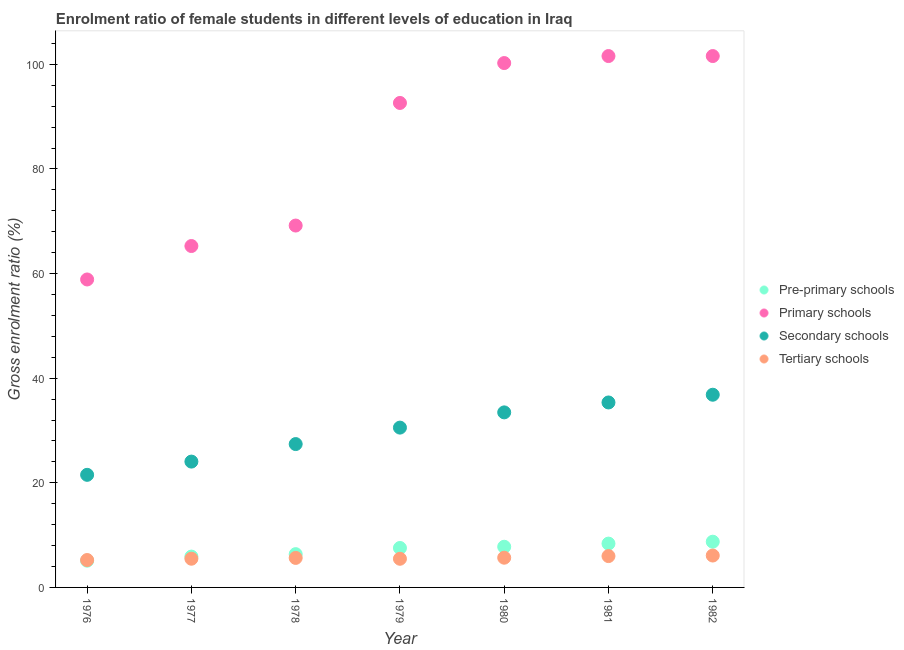What is the gross enrolment ratio(male) in pre-primary schools in 1979?
Provide a short and direct response. 7.54. Across all years, what is the maximum gross enrolment ratio(male) in tertiary schools?
Offer a very short reply. 6.1. Across all years, what is the minimum gross enrolment ratio(male) in tertiary schools?
Offer a very short reply. 5.24. In which year was the gross enrolment ratio(male) in pre-primary schools minimum?
Provide a short and direct response. 1976. What is the total gross enrolment ratio(male) in secondary schools in the graph?
Your answer should be compact. 209.22. What is the difference between the gross enrolment ratio(male) in pre-primary schools in 1977 and that in 1978?
Provide a short and direct response. -0.47. What is the difference between the gross enrolment ratio(male) in primary schools in 1979 and the gross enrolment ratio(male) in pre-primary schools in 1978?
Ensure brevity in your answer.  86.26. What is the average gross enrolment ratio(male) in primary schools per year?
Provide a short and direct response. 84.2. In the year 1982, what is the difference between the gross enrolment ratio(male) in tertiary schools and gross enrolment ratio(male) in primary schools?
Ensure brevity in your answer.  -95.49. What is the ratio of the gross enrolment ratio(male) in primary schools in 1978 to that in 1982?
Make the answer very short. 0.68. What is the difference between the highest and the second highest gross enrolment ratio(male) in primary schools?
Your answer should be very brief. 0. What is the difference between the highest and the lowest gross enrolment ratio(male) in tertiary schools?
Provide a short and direct response. 0.86. Is it the case that in every year, the sum of the gross enrolment ratio(male) in tertiary schools and gross enrolment ratio(male) in primary schools is greater than the sum of gross enrolment ratio(male) in pre-primary schools and gross enrolment ratio(male) in secondary schools?
Provide a short and direct response. Yes. Is it the case that in every year, the sum of the gross enrolment ratio(male) in pre-primary schools and gross enrolment ratio(male) in primary schools is greater than the gross enrolment ratio(male) in secondary schools?
Make the answer very short. Yes. Does the gross enrolment ratio(male) in tertiary schools monotonically increase over the years?
Your answer should be compact. No. Is the gross enrolment ratio(male) in secondary schools strictly less than the gross enrolment ratio(male) in tertiary schools over the years?
Offer a terse response. No. How many dotlines are there?
Your answer should be compact. 4. How many years are there in the graph?
Offer a terse response. 7. Are the values on the major ticks of Y-axis written in scientific E-notation?
Provide a succinct answer. No. How many legend labels are there?
Your response must be concise. 4. How are the legend labels stacked?
Make the answer very short. Vertical. What is the title of the graph?
Provide a succinct answer. Enrolment ratio of female students in different levels of education in Iraq. What is the label or title of the X-axis?
Your answer should be very brief. Year. What is the label or title of the Y-axis?
Ensure brevity in your answer.  Gross enrolment ratio (%). What is the Gross enrolment ratio (%) in Pre-primary schools in 1976?
Offer a very short reply. 5.12. What is the Gross enrolment ratio (%) of Primary schools in 1976?
Your answer should be very brief. 58.88. What is the Gross enrolment ratio (%) of Secondary schools in 1976?
Provide a short and direct response. 21.53. What is the Gross enrolment ratio (%) of Tertiary schools in 1976?
Keep it short and to the point. 5.24. What is the Gross enrolment ratio (%) of Pre-primary schools in 1977?
Give a very brief answer. 5.89. What is the Gross enrolment ratio (%) in Primary schools in 1977?
Your response must be concise. 65.27. What is the Gross enrolment ratio (%) of Secondary schools in 1977?
Offer a terse response. 24.06. What is the Gross enrolment ratio (%) of Tertiary schools in 1977?
Provide a succinct answer. 5.49. What is the Gross enrolment ratio (%) of Pre-primary schools in 1978?
Provide a succinct answer. 6.36. What is the Gross enrolment ratio (%) in Primary schools in 1978?
Your answer should be compact. 69.19. What is the Gross enrolment ratio (%) in Secondary schools in 1978?
Your answer should be compact. 27.41. What is the Gross enrolment ratio (%) of Tertiary schools in 1978?
Offer a terse response. 5.64. What is the Gross enrolment ratio (%) of Pre-primary schools in 1979?
Your response must be concise. 7.54. What is the Gross enrolment ratio (%) in Primary schools in 1979?
Provide a short and direct response. 92.63. What is the Gross enrolment ratio (%) in Secondary schools in 1979?
Your response must be concise. 30.55. What is the Gross enrolment ratio (%) in Tertiary schools in 1979?
Make the answer very short. 5.48. What is the Gross enrolment ratio (%) in Pre-primary schools in 1980?
Offer a terse response. 7.77. What is the Gross enrolment ratio (%) in Primary schools in 1980?
Your answer should be compact. 100.25. What is the Gross enrolment ratio (%) of Secondary schools in 1980?
Offer a terse response. 33.47. What is the Gross enrolment ratio (%) of Tertiary schools in 1980?
Offer a terse response. 5.68. What is the Gross enrolment ratio (%) in Pre-primary schools in 1981?
Your answer should be very brief. 8.38. What is the Gross enrolment ratio (%) in Primary schools in 1981?
Provide a short and direct response. 101.59. What is the Gross enrolment ratio (%) in Secondary schools in 1981?
Your response must be concise. 35.36. What is the Gross enrolment ratio (%) of Tertiary schools in 1981?
Offer a very short reply. 5.99. What is the Gross enrolment ratio (%) of Pre-primary schools in 1982?
Ensure brevity in your answer.  8.74. What is the Gross enrolment ratio (%) in Primary schools in 1982?
Make the answer very short. 101.59. What is the Gross enrolment ratio (%) in Secondary schools in 1982?
Keep it short and to the point. 36.84. What is the Gross enrolment ratio (%) in Tertiary schools in 1982?
Keep it short and to the point. 6.1. Across all years, what is the maximum Gross enrolment ratio (%) of Pre-primary schools?
Your answer should be compact. 8.74. Across all years, what is the maximum Gross enrolment ratio (%) of Primary schools?
Offer a terse response. 101.59. Across all years, what is the maximum Gross enrolment ratio (%) of Secondary schools?
Make the answer very short. 36.84. Across all years, what is the maximum Gross enrolment ratio (%) in Tertiary schools?
Your answer should be compact. 6.1. Across all years, what is the minimum Gross enrolment ratio (%) of Pre-primary schools?
Offer a terse response. 5.12. Across all years, what is the minimum Gross enrolment ratio (%) in Primary schools?
Keep it short and to the point. 58.88. Across all years, what is the minimum Gross enrolment ratio (%) in Secondary schools?
Provide a short and direct response. 21.53. Across all years, what is the minimum Gross enrolment ratio (%) in Tertiary schools?
Offer a very short reply. 5.24. What is the total Gross enrolment ratio (%) of Pre-primary schools in the graph?
Ensure brevity in your answer.  49.81. What is the total Gross enrolment ratio (%) of Primary schools in the graph?
Your answer should be compact. 589.4. What is the total Gross enrolment ratio (%) of Secondary schools in the graph?
Give a very brief answer. 209.22. What is the total Gross enrolment ratio (%) in Tertiary schools in the graph?
Offer a terse response. 39.62. What is the difference between the Gross enrolment ratio (%) in Pre-primary schools in 1976 and that in 1977?
Your answer should be very brief. -0.78. What is the difference between the Gross enrolment ratio (%) in Primary schools in 1976 and that in 1977?
Your response must be concise. -6.39. What is the difference between the Gross enrolment ratio (%) of Secondary schools in 1976 and that in 1977?
Your answer should be very brief. -2.53. What is the difference between the Gross enrolment ratio (%) in Tertiary schools in 1976 and that in 1977?
Offer a terse response. -0.25. What is the difference between the Gross enrolment ratio (%) of Pre-primary schools in 1976 and that in 1978?
Your answer should be very brief. -1.25. What is the difference between the Gross enrolment ratio (%) of Primary schools in 1976 and that in 1978?
Offer a terse response. -10.31. What is the difference between the Gross enrolment ratio (%) of Secondary schools in 1976 and that in 1978?
Your answer should be very brief. -5.88. What is the difference between the Gross enrolment ratio (%) of Tertiary schools in 1976 and that in 1978?
Offer a terse response. -0.4. What is the difference between the Gross enrolment ratio (%) in Pre-primary schools in 1976 and that in 1979?
Keep it short and to the point. -2.43. What is the difference between the Gross enrolment ratio (%) in Primary schools in 1976 and that in 1979?
Provide a short and direct response. -33.75. What is the difference between the Gross enrolment ratio (%) in Secondary schools in 1976 and that in 1979?
Ensure brevity in your answer.  -9.03. What is the difference between the Gross enrolment ratio (%) in Tertiary schools in 1976 and that in 1979?
Give a very brief answer. -0.24. What is the difference between the Gross enrolment ratio (%) in Pre-primary schools in 1976 and that in 1980?
Your response must be concise. -2.66. What is the difference between the Gross enrolment ratio (%) of Primary schools in 1976 and that in 1980?
Offer a terse response. -41.38. What is the difference between the Gross enrolment ratio (%) in Secondary schools in 1976 and that in 1980?
Offer a very short reply. -11.94. What is the difference between the Gross enrolment ratio (%) of Tertiary schools in 1976 and that in 1980?
Offer a terse response. -0.44. What is the difference between the Gross enrolment ratio (%) in Pre-primary schools in 1976 and that in 1981?
Offer a terse response. -3.26. What is the difference between the Gross enrolment ratio (%) in Primary schools in 1976 and that in 1981?
Keep it short and to the point. -42.71. What is the difference between the Gross enrolment ratio (%) of Secondary schools in 1976 and that in 1981?
Your answer should be compact. -13.84. What is the difference between the Gross enrolment ratio (%) of Tertiary schools in 1976 and that in 1981?
Provide a short and direct response. -0.75. What is the difference between the Gross enrolment ratio (%) in Pre-primary schools in 1976 and that in 1982?
Offer a very short reply. -3.63. What is the difference between the Gross enrolment ratio (%) in Primary schools in 1976 and that in 1982?
Your response must be concise. -42.71. What is the difference between the Gross enrolment ratio (%) of Secondary schools in 1976 and that in 1982?
Provide a short and direct response. -15.31. What is the difference between the Gross enrolment ratio (%) in Tertiary schools in 1976 and that in 1982?
Give a very brief answer. -0.86. What is the difference between the Gross enrolment ratio (%) of Pre-primary schools in 1977 and that in 1978?
Provide a short and direct response. -0.47. What is the difference between the Gross enrolment ratio (%) of Primary schools in 1977 and that in 1978?
Ensure brevity in your answer.  -3.91. What is the difference between the Gross enrolment ratio (%) of Secondary schools in 1977 and that in 1978?
Provide a succinct answer. -3.35. What is the difference between the Gross enrolment ratio (%) of Tertiary schools in 1977 and that in 1978?
Provide a short and direct response. -0.15. What is the difference between the Gross enrolment ratio (%) in Pre-primary schools in 1977 and that in 1979?
Ensure brevity in your answer.  -1.65. What is the difference between the Gross enrolment ratio (%) of Primary schools in 1977 and that in 1979?
Give a very brief answer. -27.35. What is the difference between the Gross enrolment ratio (%) in Secondary schools in 1977 and that in 1979?
Offer a terse response. -6.5. What is the difference between the Gross enrolment ratio (%) in Tertiary schools in 1977 and that in 1979?
Offer a terse response. 0.01. What is the difference between the Gross enrolment ratio (%) in Pre-primary schools in 1977 and that in 1980?
Your response must be concise. -1.88. What is the difference between the Gross enrolment ratio (%) of Primary schools in 1977 and that in 1980?
Give a very brief answer. -34.98. What is the difference between the Gross enrolment ratio (%) in Secondary schools in 1977 and that in 1980?
Make the answer very short. -9.41. What is the difference between the Gross enrolment ratio (%) in Tertiary schools in 1977 and that in 1980?
Offer a terse response. -0.19. What is the difference between the Gross enrolment ratio (%) in Pre-primary schools in 1977 and that in 1981?
Provide a succinct answer. -2.49. What is the difference between the Gross enrolment ratio (%) of Primary schools in 1977 and that in 1981?
Keep it short and to the point. -36.32. What is the difference between the Gross enrolment ratio (%) in Secondary schools in 1977 and that in 1981?
Ensure brevity in your answer.  -11.31. What is the difference between the Gross enrolment ratio (%) of Tertiary schools in 1977 and that in 1981?
Give a very brief answer. -0.5. What is the difference between the Gross enrolment ratio (%) in Pre-primary schools in 1977 and that in 1982?
Keep it short and to the point. -2.85. What is the difference between the Gross enrolment ratio (%) of Primary schools in 1977 and that in 1982?
Provide a succinct answer. -36.32. What is the difference between the Gross enrolment ratio (%) of Secondary schools in 1977 and that in 1982?
Provide a short and direct response. -12.78. What is the difference between the Gross enrolment ratio (%) of Tertiary schools in 1977 and that in 1982?
Your response must be concise. -0.61. What is the difference between the Gross enrolment ratio (%) in Pre-primary schools in 1978 and that in 1979?
Offer a very short reply. -1.18. What is the difference between the Gross enrolment ratio (%) in Primary schools in 1978 and that in 1979?
Your answer should be compact. -23.44. What is the difference between the Gross enrolment ratio (%) in Secondary schools in 1978 and that in 1979?
Give a very brief answer. -3.15. What is the difference between the Gross enrolment ratio (%) of Tertiary schools in 1978 and that in 1979?
Your response must be concise. 0.16. What is the difference between the Gross enrolment ratio (%) of Pre-primary schools in 1978 and that in 1980?
Ensure brevity in your answer.  -1.41. What is the difference between the Gross enrolment ratio (%) in Primary schools in 1978 and that in 1980?
Provide a short and direct response. -31.07. What is the difference between the Gross enrolment ratio (%) of Secondary schools in 1978 and that in 1980?
Your answer should be very brief. -6.06. What is the difference between the Gross enrolment ratio (%) in Tertiary schools in 1978 and that in 1980?
Provide a short and direct response. -0.04. What is the difference between the Gross enrolment ratio (%) in Pre-primary schools in 1978 and that in 1981?
Provide a succinct answer. -2.02. What is the difference between the Gross enrolment ratio (%) in Primary schools in 1978 and that in 1981?
Provide a succinct answer. -32.41. What is the difference between the Gross enrolment ratio (%) of Secondary schools in 1978 and that in 1981?
Your response must be concise. -7.96. What is the difference between the Gross enrolment ratio (%) in Tertiary schools in 1978 and that in 1981?
Your answer should be compact. -0.35. What is the difference between the Gross enrolment ratio (%) of Pre-primary schools in 1978 and that in 1982?
Provide a short and direct response. -2.38. What is the difference between the Gross enrolment ratio (%) in Primary schools in 1978 and that in 1982?
Offer a terse response. -32.41. What is the difference between the Gross enrolment ratio (%) of Secondary schools in 1978 and that in 1982?
Make the answer very short. -9.43. What is the difference between the Gross enrolment ratio (%) of Tertiary schools in 1978 and that in 1982?
Your response must be concise. -0.45. What is the difference between the Gross enrolment ratio (%) of Pre-primary schools in 1979 and that in 1980?
Offer a very short reply. -0.23. What is the difference between the Gross enrolment ratio (%) in Primary schools in 1979 and that in 1980?
Your response must be concise. -7.63. What is the difference between the Gross enrolment ratio (%) of Secondary schools in 1979 and that in 1980?
Your answer should be very brief. -2.91. What is the difference between the Gross enrolment ratio (%) of Tertiary schools in 1979 and that in 1980?
Provide a short and direct response. -0.2. What is the difference between the Gross enrolment ratio (%) of Pre-primary schools in 1979 and that in 1981?
Your answer should be very brief. -0.84. What is the difference between the Gross enrolment ratio (%) of Primary schools in 1979 and that in 1981?
Offer a very short reply. -8.97. What is the difference between the Gross enrolment ratio (%) of Secondary schools in 1979 and that in 1981?
Your answer should be very brief. -4.81. What is the difference between the Gross enrolment ratio (%) in Tertiary schools in 1979 and that in 1981?
Provide a short and direct response. -0.51. What is the difference between the Gross enrolment ratio (%) of Pre-primary schools in 1979 and that in 1982?
Offer a very short reply. -1.2. What is the difference between the Gross enrolment ratio (%) of Primary schools in 1979 and that in 1982?
Give a very brief answer. -8.97. What is the difference between the Gross enrolment ratio (%) in Secondary schools in 1979 and that in 1982?
Offer a very short reply. -6.29. What is the difference between the Gross enrolment ratio (%) in Tertiary schools in 1979 and that in 1982?
Ensure brevity in your answer.  -0.62. What is the difference between the Gross enrolment ratio (%) of Pre-primary schools in 1980 and that in 1981?
Offer a terse response. -0.6. What is the difference between the Gross enrolment ratio (%) in Primary schools in 1980 and that in 1981?
Ensure brevity in your answer.  -1.34. What is the difference between the Gross enrolment ratio (%) of Secondary schools in 1980 and that in 1981?
Provide a succinct answer. -1.9. What is the difference between the Gross enrolment ratio (%) in Tertiary schools in 1980 and that in 1981?
Keep it short and to the point. -0.31. What is the difference between the Gross enrolment ratio (%) in Pre-primary schools in 1980 and that in 1982?
Your answer should be compact. -0.97. What is the difference between the Gross enrolment ratio (%) of Primary schools in 1980 and that in 1982?
Provide a succinct answer. -1.34. What is the difference between the Gross enrolment ratio (%) in Secondary schools in 1980 and that in 1982?
Provide a short and direct response. -3.37. What is the difference between the Gross enrolment ratio (%) in Tertiary schools in 1980 and that in 1982?
Your response must be concise. -0.41. What is the difference between the Gross enrolment ratio (%) of Pre-primary schools in 1981 and that in 1982?
Ensure brevity in your answer.  -0.36. What is the difference between the Gross enrolment ratio (%) of Primary schools in 1981 and that in 1982?
Your answer should be very brief. -0. What is the difference between the Gross enrolment ratio (%) in Secondary schools in 1981 and that in 1982?
Give a very brief answer. -1.48. What is the difference between the Gross enrolment ratio (%) in Tertiary schools in 1981 and that in 1982?
Give a very brief answer. -0.1. What is the difference between the Gross enrolment ratio (%) of Pre-primary schools in 1976 and the Gross enrolment ratio (%) of Primary schools in 1977?
Provide a short and direct response. -60.16. What is the difference between the Gross enrolment ratio (%) in Pre-primary schools in 1976 and the Gross enrolment ratio (%) in Secondary schools in 1977?
Provide a succinct answer. -18.94. What is the difference between the Gross enrolment ratio (%) of Pre-primary schools in 1976 and the Gross enrolment ratio (%) of Tertiary schools in 1977?
Offer a very short reply. -0.37. What is the difference between the Gross enrolment ratio (%) in Primary schools in 1976 and the Gross enrolment ratio (%) in Secondary schools in 1977?
Ensure brevity in your answer.  34.82. What is the difference between the Gross enrolment ratio (%) in Primary schools in 1976 and the Gross enrolment ratio (%) in Tertiary schools in 1977?
Provide a succinct answer. 53.39. What is the difference between the Gross enrolment ratio (%) in Secondary schools in 1976 and the Gross enrolment ratio (%) in Tertiary schools in 1977?
Your answer should be very brief. 16.04. What is the difference between the Gross enrolment ratio (%) in Pre-primary schools in 1976 and the Gross enrolment ratio (%) in Primary schools in 1978?
Offer a very short reply. -64.07. What is the difference between the Gross enrolment ratio (%) of Pre-primary schools in 1976 and the Gross enrolment ratio (%) of Secondary schools in 1978?
Your response must be concise. -22.29. What is the difference between the Gross enrolment ratio (%) of Pre-primary schools in 1976 and the Gross enrolment ratio (%) of Tertiary schools in 1978?
Offer a very short reply. -0.53. What is the difference between the Gross enrolment ratio (%) of Primary schools in 1976 and the Gross enrolment ratio (%) of Secondary schools in 1978?
Provide a short and direct response. 31.47. What is the difference between the Gross enrolment ratio (%) of Primary schools in 1976 and the Gross enrolment ratio (%) of Tertiary schools in 1978?
Your answer should be very brief. 53.24. What is the difference between the Gross enrolment ratio (%) in Secondary schools in 1976 and the Gross enrolment ratio (%) in Tertiary schools in 1978?
Offer a terse response. 15.88. What is the difference between the Gross enrolment ratio (%) in Pre-primary schools in 1976 and the Gross enrolment ratio (%) in Primary schools in 1979?
Offer a terse response. -87.51. What is the difference between the Gross enrolment ratio (%) of Pre-primary schools in 1976 and the Gross enrolment ratio (%) of Secondary schools in 1979?
Ensure brevity in your answer.  -25.44. What is the difference between the Gross enrolment ratio (%) in Pre-primary schools in 1976 and the Gross enrolment ratio (%) in Tertiary schools in 1979?
Make the answer very short. -0.36. What is the difference between the Gross enrolment ratio (%) in Primary schools in 1976 and the Gross enrolment ratio (%) in Secondary schools in 1979?
Your answer should be compact. 28.32. What is the difference between the Gross enrolment ratio (%) of Primary schools in 1976 and the Gross enrolment ratio (%) of Tertiary schools in 1979?
Offer a terse response. 53.4. What is the difference between the Gross enrolment ratio (%) in Secondary schools in 1976 and the Gross enrolment ratio (%) in Tertiary schools in 1979?
Your answer should be compact. 16.05. What is the difference between the Gross enrolment ratio (%) of Pre-primary schools in 1976 and the Gross enrolment ratio (%) of Primary schools in 1980?
Your response must be concise. -95.14. What is the difference between the Gross enrolment ratio (%) of Pre-primary schools in 1976 and the Gross enrolment ratio (%) of Secondary schools in 1980?
Make the answer very short. -28.35. What is the difference between the Gross enrolment ratio (%) of Pre-primary schools in 1976 and the Gross enrolment ratio (%) of Tertiary schools in 1980?
Give a very brief answer. -0.57. What is the difference between the Gross enrolment ratio (%) in Primary schools in 1976 and the Gross enrolment ratio (%) in Secondary schools in 1980?
Ensure brevity in your answer.  25.41. What is the difference between the Gross enrolment ratio (%) in Primary schools in 1976 and the Gross enrolment ratio (%) in Tertiary schools in 1980?
Make the answer very short. 53.2. What is the difference between the Gross enrolment ratio (%) in Secondary schools in 1976 and the Gross enrolment ratio (%) in Tertiary schools in 1980?
Offer a terse response. 15.84. What is the difference between the Gross enrolment ratio (%) in Pre-primary schools in 1976 and the Gross enrolment ratio (%) in Primary schools in 1981?
Keep it short and to the point. -96.48. What is the difference between the Gross enrolment ratio (%) in Pre-primary schools in 1976 and the Gross enrolment ratio (%) in Secondary schools in 1981?
Give a very brief answer. -30.25. What is the difference between the Gross enrolment ratio (%) in Pre-primary schools in 1976 and the Gross enrolment ratio (%) in Tertiary schools in 1981?
Offer a very short reply. -0.88. What is the difference between the Gross enrolment ratio (%) of Primary schools in 1976 and the Gross enrolment ratio (%) of Secondary schools in 1981?
Ensure brevity in your answer.  23.51. What is the difference between the Gross enrolment ratio (%) of Primary schools in 1976 and the Gross enrolment ratio (%) of Tertiary schools in 1981?
Offer a very short reply. 52.88. What is the difference between the Gross enrolment ratio (%) of Secondary schools in 1976 and the Gross enrolment ratio (%) of Tertiary schools in 1981?
Give a very brief answer. 15.53. What is the difference between the Gross enrolment ratio (%) of Pre-primary schools in 1976 and the Gross enrolment ratio (%) of Primary schools in 1982?
Provide a succinct answer. -96.48. What is the difference between the Gross enrolment ratio (%) of Pre-primary schools in 1976 and the Gross enrolment ratio (%) of Secondary schools in 1982?
Your answer should be very brief. -31.72. What is the difference between the Gross enrolment ratio (%) in Pre-primary schools in 1976 and the Gross enrolment ratio (%) in Tertiary schools in 1982?
Offer a very short reply. -0.98. What is the difference between the Gross enrolment ratio (%) in Primary schools in 1976 and the Gross enrolment ratio (%) in Secondary schools in 1982?
Offer a terse response. 22.04. What is the difference between the Gross enrolment ratio (%) of Primary schools in 1976 and the Gross enrolment ratio (%) of Tertiary schools in 1982?
Your answer should be compact. 52.78. What is the difference between the Gross enrolment ratio (%) of Secondary schools in 1976 and the Gross enrolment ratio (%) of Tertiary schools in 1982?
Keep it short and to the point. 15.43. What is the difference between the Gross enrolment ratio (%) in Pre-primary schools in 1977 and the Gross enrolment ratio (%) in Primary schools in 1978?
Ensure brevity in your answer.  -63.29. What is the difference between the Gross enrolment ratio (%) in Pre-primary schools in 1977 and the Gross enrolment ratio (%) in Secondary schools in 1978?
Offer a terse response. -21.51. What is the difference between the Gross enrolment ratio (%) in Pre-primary schools in 1977 and the Gross enrolment ratio (%) in Tertiary schools in 1978?
Your answer should be very brief. 0.25. What is the difference between the Gross enrolment ratio (%) in Primary schools in 1977 and the Gross enrolment ratio (%) in Secondary schools in 1978?
Your answer should be compact. 37.86. What is the difference between the Gross enrolment ratio (%) of Primary schools in 1977 and the Gross enrolment ratio (%) of Tertiary schools in 1978?
Your response must be concise. 59.63. What is the difference between the Gross enrolment ratio (%) of Secondary schools in 1977 and the Gross enrolment ratio (%) of Tertiary schools in 1978?
Offer a terse response. 18.42. What is the difference between the Gross enrolment ratio (%) in Pre-primary schools in 1977 and the Gross enrolment ratio (%) in Primary schools in 1979?
Provide a succinct answer. -86.73. What is the difference between the Gross enrolment ratio (%) of Pre-primary schools in 1977 and the Gross enrolment ratio (%) of Secondary schools in 1979?
Ensure brevity in your answer.  -24.66. What is the difference between the Gross enrolment ratio (%) in Pre-primary schools in 1977 and the Gross enrolment ratio (%) in Tertiary schools in 1979?
Give a very brief answer. 0.42. What is the difference between the Gross enrolment ratio (%) in Primary schools in 1977 and the Gross enrolment ratio (%) in Secondary schools in 1979?
Make the answer very short. 34.72. What is the difference between the Gross enrolment ratio (%) of Primary schools in 1977 and the Gross enrolment ratio (%) of Tertiary schools in 1979?
Provide a short and direct response. 59.79. What is the difference between the Gross enrolment ratio (%) of Secondary schools in 1977 and the Gross enrolment ratio (%) of Tertiary schools in 1979?
Provide a short and direct response. 18.58. What is the difference between the Gross enrolment ratio (%) in Pre-primary schools in 1977 and the Gross enrolment ratio (%) in Primary schools in 1980?
Your answer should be very brief. -94.36. What is the difference between the Gross enrolment ratio (%) in Pre-primary schools in 1977 and the Gross enrolment ratio (%) in Secondary schools in 1980?
Offer a terse response. -27.57. What is the difference between the Gross enrolment ratio (%) of Pre-primary schools in 1977 and the Gross enrolment ratio (%) of Tertiary schools in 1980?
Your answer should be compact. 0.21. What is the difference between the Gross enrolment ratio (%) of Primary schools in 1977 and the Gross enrolment ratio (%) of Secondary schools in 1980?
Your answer should be compact. 31.81. What is the difference between the Gross enrolment ratio (%) in Primary schools in 1977 and the Gross enrolment ratio (%) in Tertiary schools in 1980?
Keep it short and to the point. 59.59. What is the difference between the Gross enrolment ratio (%) of Secondary schools in 1977 and the Gross enrolment ratio (%) of Tertiary schools in 1980?
Give a very brief answer. 18.38. What is the difference between the Gross enrolment ratio (%) of Pre-primary schools in 1977 and the Gross enrolment ratio (%) of Primary schools in 1981?
Your answer should be compact. -95.7. What is the difference between the Gross enrolment ratio (%) of Pre-primary schools in 1977 and the Gross enrolment ratio (%) of Secondary schools in 1981?
Keep it short and to the point. -29.47. What is the difference between the Gross enrolment ratio (%) in Pre-primary schools in 1977 and the Gross enrolment ratio (%) in Tertiary schools in 1981?
Your answer should be compact. -0.1. What is the difference between the Gross enrolment ratio (%) of Primary schools in 1977 and the Gross enrolment ratio (%) of Secondary schools in 1981?
Make the answer very short. 29.91. What is the difference between the Gross enrolment ratio (%) in Primary schools in 1977 and the Gross enrolment ratio (%) in Tertiary schools in 1981?
Keep it short and to the point. 59.28. What is the difference between the Gross enrolment ratio (%) in Secondary schools in 1977 and the Gross enrolment ratio (%) in Tertiary schools in 1981?
Make the answer very short. 18.07. What is the difference between the Gross enrolment ratio (%) of Pre-primary schools in 1977 and the Gross enrolment ratio (%) of Primary schools in 1982?
Provide a short and direct response. -95.7. What is the difference between the Gross enrolment ratio (%) in Pre-primary schools in 1977 and the Gross enrolment ratio (%) in Secondary schools in 1982?
Ensure brevity in your answer.  -30.95. What is the difference between the Gross enrolment ratio (%) in Pre-primary schools in 1977 and the Gross enrolment ratio (%) in Tertiary schools in 1982?
Provide a short and direct response. -0.2. What is the difference between the Gross enrolment ratio (%) in Primary schools in 1977 and the Gross enrolment ratio (%) in Secondary schools in 1982?
Provide a short and direct response. 28.43. What is the difference between the Gross enrolment ratio (%) in Primary schools in 1977 and the Gross enrolment ratio (%) in Tertiary schools in 1982?
Keep it short and to the point. 59.17. What is the difference between the Gross enrolment ratio (%) of Secondary schools in 1977 and the Gross enrolment ratio (%) of Tertiary schools in 1982?
Make the answer very short. 17.96. What is the difference between the Gross enrolment ratio (%) of Pre-primary schools in 1978 and the Gross enrolment ratio (%) of Primary schools in 1979?
Offer a terse response. -86.26. What is the difference between the Gross enrolment ratio (%) in Pre-primary schools in 1978 and the Gross enrolment ratio (%) in Secondary schools in 1979?
Make the answer very short. -24.19. What is the difference between the Gross enrolment ratio (%) of Pre-primary schools in 1978 and the Gross enrolment ratio (%) of Tertiary schools in 1979?
Provide a short and direct response. 0.88. What is the difference between the Gross enrolment ratio (%) in Primary schools in 1978 and the Gross enrolment ratio (%) in Secondary schools in 1979?
Keep it short and to the point. 38.63. What is the difference between the Gross enrolment ratio (%) of Primary schools in 1978 and the Gross enrolment ratio (%) of Tertiary schools in 1979?
Offer a terse response. 63.71. What is the difference between the Gross enrolment ratio (%) of Secondary schools in 1978 and the Gross enrolment ratio (%) of Tertiary schools in 1979?
Your answer should be compact. 21.93. What is the difference between the Gross enrolment ratio (%) of Pre-primary schools in 1978 and the Gross enrolment ratio (%) of Primary schools in 1980?
Make the answer very short. -93.89. What is the difference between the Gross enrolment ratio (%) in Pre-primary schools in 1978 and the Gross enrolment ratio (%) in Secondary schools in 1980?
Provide a succinct answer. -27.1. What is the difference between the Gross enrolment ratio (%) in Pre-primary schools in 1978 and the Gross enrolment ratio (%) in Tertiary schools in 1980?
Your answer should be very brief. 0.68. What is the difference between the Gross enrolment ratio (%) of Primary schools in 1978 and the Gross enrolment ratio (%) of Secondary schools in 1980?
Your answer should be very brief. 35.72. What is the difference between the Gross enrolment ratio (%) in Primary schools in 1978 and the Gross enrolment ratio (%) in Tertiary schools in 1980?
Your response must be concise. 63.5. What is the difference between the Gross enrolment ratio (%) in Secondary schools in 1978 and the Gross enrolment ratio (%) in Tertiary schools in 1980?
Make the answer very short. 21.73. What is the difference between the Gross enrolment ratio (%) of Pre-primary schools in 1978 and the Gross enrolment ratio (%) of Primary schools in 1981?
Offer a very short reply. -95.23. What is the difference between the Gross enrolment ratio (%) in Pre-primary schools in 1978 and the Gross enrolment ratio (%) in Secondary schools in 1981?
Keep it short and to the point. -29. What is the difference between the Gross enrolment ratio (%) in Pre-primary schools in 1978 and the Gross enrolment ratio (%) in Tertiary schools in 1981?
Offer a very short reply. 0.37. What is the difference between the Gross enrolment ratio (%) in Primary schools in 1978 and the Gross enrolment ratio (%) in Secondary schools in 1981?
Provide a succinct answer. 33.82. What is the difference between the Gross enrolment ratio (%) of Primary schools in 1978 and the Gross enrolment ratio (%) of Tertiary schools in 1981?
Your response must be concise. 63.19. What is the difference between the Gross enrolment ratio (%) of Secondary schools in 1978 and the Gross enrolment ratio (%) of Tertiary schools in 1981?
Offer a terse response. 21.42. What is the difference between the Gross enrolment ratio (%) in Pre-primary schools in 1978 and the Gross enrolment ratio (%) in Primary schools in 1982?
Provide a succinct answer. -95.23. What is the difference between the Gross enrolment ratio (%) of Pre-primary schools in 1978 and the Gross enrolment ratio (%) of Secondary schools in 1982?
Make the answer very short. -30.48. What is the difference between the Gross enrolment ratio (%) of Pre-primary schools in 1978 and the Gross enrolment ratio (%) of Tertiary schools in 1982?
Your answer should be very brief. 0.26. What is the difference between the Gross enrolment ratio (%) of Primary schools in 1978 and the Gross enrolment ratio (%) of Secondary schools in 1982?
Offer a terse response. 32.35. What is the difference between the Gross enrolment ratio (%) in Primary schools in 1978 and the Gross enrolment ratio (%) in Tertiary schools in 1982?
Your answer should be compact. 63.09. What is the difference between the Gross enrolment ratio (%) of Secondary schools in 1978 and the Gross enrolment ratio (%) of Tertiary schools in 1982?
Give a very brief answer. 21.31. What is the difference between the Gross enrolment ratio (%) of Pre-primary schools in 1979 and the Gross enrolment ratio (%) of Primary schools in 1980?
Provide a short and direct response. -92.71. What is the difference between the Gross enrolment ratio (%) of Pre-primary schools in 1979 and the Gross enrolment ratio (%) of Secondary schools in 1980?
Offer a very short reply. -25.92. What is the difference between the Gross enrolment ratio (%) in Pre-primary schools in 1979 and the Gross enrolment ratio (%) in Tertiary schools in 1980?
Provide a succinct answer. 1.86. What is the difference between the Gross enrolment ratio (%) of Primary schools in 1979 and the Gross enrolment ratio (%) of Secondary schools in 1980?
Your answer should be very brief. 59.16. What is the difference between the Gross enrolment ratio (%) of Primary schools in 1979 and the Gross enrolment ratio (%) of Tertiary schools in 1980?
Offer a very short reply. 86.94. What is the difference between the Gross enrolment ratio (%) of Secondary schools in 1979 and the Gross enrolment ratio (%) of Tertiary schools in 1980?
Offer a very short reply. 24.87. What is the difference between the Gross enrolment ratio (%) in Pre-primary schools in 1979 and the Gross enrolment ratio (%) in Primary schools in 1981?
Give a very brief answer. -94.05. What is the difference between the Gross enrolment ratio (%) in Pre-primary schools in 1979 and the Gross enrolment ratio (%) in Secondary schools in 1981?
Offer a very short reply. -27.82. What is the difference between the Gross enrolment ratio (%) of Pre-primary schools in 1979 and the Gross enrolment ratio (%) of Tertiary schools in 1981?
Give a very brief answer. 1.55. What is the difference between the Gross enrolment ratio (%) of Primary schools in 1979 and the Gross enrolment ratio (%) of Secondary schools in 1981?
Your answer should be compact. 57.26. What is the difference between the Gross enrolment ratio (%) in Primary schools in 1979 and the Gross enrolment ratio (%) in Tertiary schools in 1981?
Keep it short and to the point. 86.63. What is the difference between the Gross enrolment ratio (%) of Secondary schools in 1979 and the Gross enrolment ratio (%) of Tertiary schools in 1981?
Make the answer very short. 24.56. What is the difference between the Gross enrolment ratio (%) in Pre-primary schools in 1979 and the Gross enrolment ratio (%) in Primary schools in 1982?
Keep it short and to the point. -94.05. What is the difference between the Gross enrolment ratio (%) in Pre-primary schools in 1979 and the Gross enrolment ratio (%) in Secondary schools in 1982?
Your answer should be compact. -29.3. What is the difference between the Gross enrolment ratio (%) of Pre-primary schools in 1979 and the Gross enrolment ratio (%) of Tertiary schools in 1982?
Provide a short and direct response. 1.45. What is the difference between the Gross enrolment ratio (%) of Primary schools in 1979 and the Gross enrolment ratio (%) of Secondary schools in 1982?
Give a very brief answer. 55.78. What is the difference between the Gross enrolment ratio (%) in Primary schools in 1979 and the Gross enrolment ratio (%) in Tertiary schools in 1982?
Offer a terse response. 86.53. What is the difference between the Gross enrolment ratio (%) in Secondary schools in 1979 and the Gross enrolment ratio (%) in Tertiary schools in 1982?
Your response must be concise. 24.46. What is the difference between the Gross enrolment ratio (%) in Pre-primary schools in 1980 and the Gross enrolment ratio (%) in Primary schools in 1981?
Ensure brevity in your answer.  -93.82. What is the difference between the Gross enrolment ratio (%) of Pre-primary schools in 1980 and the Gross enrolment ratio (%) of Secondary schools in 1981?
Ensure brevity in your answer.  -27.59. What is the difference between the Gross enrolment ratio (%) in Pre-primary schools in 1980 and the Gross enrolment ratio (%) in Tertiary schools in 1981?
Make the answer very short. 1.78. What is the difference between the Gross enrolment ratio (%) in Primary schools in 1980 and the Gross enrolment ratio (%) in Secondary schools in 1981?
Provide a succinct answer. 64.89. What is the difference between the Gross enrolment ratio (%) of Primary schools in 1980 and the Gross enrolment ratio (%) of Tertiary schools in 1981?
Keep it short and to the point. 94.26. What is the difference between the Gross enrolment ratio (%) of Secondary schools in 1980 and the Gross enrolment ratio (%) of Tertiary schools in 1981?
Provide a short and direct response. 27.47. What is the difference between the Gross enrolment ratio (%) in Pre-primary schools in 1980 and the Gross enrolment ratio (%) in Primary schools in 1982?
Your answer should be compact. -93.82. What is the difference between the Gross enrolment ratio (%) in Pre-primary schools in 1980 and the Gross enrolment ratio (%) in Secondary schools in 1982?
Your response must be concise. -29.07. What is the difference between the Gross enrolment ratio (%) in Pre-primary schools in 1980 and the Gross enrolment ratio (%) in Tertiary schools in 1982?
Your answer should be compact. 1.68. What is the difference between the Gross enrolment ratio (%) of Primary schools in 1980 and the Gross enrolment ratio (%) of Secondary schools in 1982?
Provide a succinct answer. 63.41. What is the difference between the Gross enrolment ratio (%) of Primary schools in 1980 and the Gross enrolment ratio (%) of Tertiary schools in 1982?
Offer a terse response. 94.16. What is the difference between the Gross enrolment ratio (%) in Secondary schools in 1980 and the Gross enrolment ratio (%) in Tertiary schools in 1982?
Provide a succinct answer. 27.37. What is the difference between the Gross enrolment ratio (%) in Pre-primary schools in 1981 and the Gross enrolment ratio (%) in Primary schools in 1982?
Your answer should be very brief. -93.21. What is the difference between the Gross enrolment ratio (%) of Pre-primary schools in 1981 and the Gross enrolment ratio (%) of Secondary schools in 1982?
Your answer should be compact. -28.46. What is the difference between the Gross enrolment ratio (%) of Pre-primary schools in 1981 and the Gross enrolment ratio (%) of Tertiary schools in 1982?
Your response must be concise. 2.28. What is the difference between the Gross enrolment ratio (%) in Primary schools in 1981 and the Gross enrolment ratio (%) in Secondary schools in 1982?
Offer a very short reply. 64.75. What is the difference between the Gross enrolment ratio (%) in Primary schools in 1981 and the Gross enrolment ratio (%) in Tertiary schools in 1982?
Provide a succinct answer. 95.49. What is the difference between the Gross enrolment ratio (%) in Secondary schools in 1981 and the Gross enrolment ratio (%) in Tertiary schools in 1982?
Provide a succinct answer. 29.27. What is the average Gross enrolment ratio (%) in Pre-primary schools per year?
Ensure brevity in your answer.  7.12. What is the average Gross enrolment ratio (%) of Primary schools per year?
Provide a succinct answer. 84.2. What is the average Gross enrolment ratio (%) in Secondary schools per year?
Your response must be concise. 29.89. What is the average Gross enrolment ratio (%) in Tertiary schools per year?
Provide a short and direct response. 5.66. In the year 1976, what is the difference between the Gross enrolment ratio (%) of Pre-primary schools and Gross enrolment ratio (%) of Primary schools?
Offer a very short reply. -53.76. In the year 1976, what is the difference between the Gross enrolment ratio (%) in Pre-primary schools and Gross enrolment ratio (%) in Secondary schools?
Offer a very short reply. -16.41. In the year 1976, what is the difference between the Gross enrolment ratio (%) of Pre-primary schools and Gross enrolment ratio (%) of Tertiary schools?
Give a very brief answer. -0.12. In the year 1976, what is the difference between the Gross enrolment ratio (%) in Primary schools and Gross enrolment ratio (%) in Secondary schools?
Give a very brief answer. 37.35. In the year 1976, what is the difference between the Gross enrolment ratio (%) in Primary schools and Gross enrolment ratio (%) in Tertiary schools?
Your response must be concise. 53.64. In the year 1976, what is the difference between the Gross enrolment ratio (%) of Secondary schools and Gross enrolment ratio (%) of Tertiary schools?
Give a very brief answer. 16.29. In the year 1977, what is the difference between the Gross enrolment ratio (%) of Pre-primary schools and Gross enrolment ratio (%) of Primary schools?
Keep it short and to the point. -59.38. In the year 1977, what is the difference between the Gross enrolment ratio (%) in Pre-primary schools and Gross enrolment ratio (%) in Secondary schools?
Keep it short and to the point. -18.16. In the year 1977, what is the difference between the Gross enrolment ratio (%) in Pre-primary schools and Gross enrolment ratio (%) in Tertiary schools?
Offer a terse response. 0.41. In the year 1977, what is the difference between the Gross enrolment ratio (%) in Primary schools and Gross enrolment ratio (%) in Secondary schools?
Make the answer very short. 41.21. In the year 1977, what is the difference between the Gross enrolment ratio (%) of Primary schools and Gross enrolment ratio (%) of Tertiary schools?
Give a very brief answer. 59.78. In the year 1977, what is the difference between the Gross enrolment ratio (%) in Secondary schools and Gross enrolment ratio (%) in Tertiary schools?
Make the answer very short. 18.57. In the year 1978, what is the difference between the Gross enrolment ratio (%) of Pre-primary schools and Gross enrolment ratio (%) of Primary schools?
Ensure brevity in your answer.  -62.82. In the year 1978, what is the difference between the Gross enrolment ratio (%) of Pre-primary schools and Gross enrolment ratio (%) of Secondary schools?
Your answer should be very brief. -21.05. In the year 1978, what is the difference between the Gross enrolment ratio (%) of Pre-primary schools and Gross enrolment ratio (%) of Tertiary schools?
Make the answer very short. 0.72. In the year 1978, what is the difference between the Gross enrolment ratio (%) of Primary schools and Gross enrolment ratio (%) of Secondary schools?
Provide a succinct answer. 41.78. In the year 1978, what is the difference between the Gross enrolment ratio (%) in Primary schools and Gross enrolment ratio (%) in Tertiary schools?
Make the answer very short. 63.54. In the year 1978, what is the difference between the Gross enrolment ratio (%) of Secondary schools and Gross enrolment ratio (%) of Tertiary schools?
Provide a succinct answer. 21.77. In the year 1979, what is the difference between the Gross enrolment ratio (%) in Pre-primary schools and Gross enrolment ratio (%) in Primary schools?
Give a very brief answer. -85.08. In the year 1979, what is the difference between the Gross enrolment ratio (%) of Pre-primary schools and Gross enrolment ratio (%) of Secondary schools?
Provide a short and direct response. -23.01. In the year 1979, what is the difference between the Gross enrolment ratio (%) in Pre-primary schools and Gross enrolment ratio (%) in Tertiary schools?
Your answer should be very brief. 2.06. In the year 1979, what is the difference between the Gross enrolment ratio (%) in Primary schools and Gross enrolment ratio (%) in Secondary schools?
Your answer should be very brief. 62.07. In the year 1979, what is the difference between the Gross enrolment ratio (%) in Primary schools and Gross enrolment ratio (%) in Tertiary schools?
Your answer should be very brief. 87.15. In the year 1979, what is the difference between the Gross enrolment ratio (%) in Secondary schools and Gross enrolment ratio (%) in Tertiary schools?
Make the answer very short. 25.08. In the year 1980, what is the difference between the Gross enrolment ratio (%) in Pre-primary schools and Gross enrolment ratio (%) in Primary schools?
Give a very brief answer. -92.48. In the year 1980, what is the difference between the Gross enrolment ratio (%) in Pre-primary schools and Gross enrolment ratio (%) in Secondary schools?
Make the answer very short. -25.69. In the year 1980, what is the difference between the Gross enrolment ratio (%) in Pre-primary schools and Gross enrolment ratio (%) in Tertiary schools?
Offer a terse response. 2.09. In the year 1980, what is the difference between the Gross enrolment ratio (%) in Primary schools and Gross enrolment ratio (%) in Secondary schools?
Offer a very short reply. 66.79. In the year 1980, what is the difference between the Gross enrolment ratio (%) of Primary schools and Gross enrolment ratio (%) of Tertiary schools?
Your answer should be very brief. 94.57. In the year 1980, what is the difference between the Gross enrolment ratio (%) of Secondary schools and Gross enrolment ratio (%) of Tertiary schools?
Provide a succinct answer. 27.78. In the year 1981, what is the difference between the Gross enrolment ratio (%) of Pre-primary schools and Gross enrolment ratio (%) of Primary schools?
Ensure brevity in your answer.  -93.21. In the year 1981, what is the difference between the Gross enrolment ratio (%) of Pre-primary schools and Gross enrolment ratio (%) of Secondary schools?
Provide a short and direct response. -26.98. In the year 1981, what is the difference between the Gross enrolment ratio (%) of Pre-primary schools and Gross enrolment ratio (%) of Tertiary schools?
Offer a very short reply. 2.39. In the year 1981, what is the difference between the Gross enrolment ratio (%) in Primary schools and Gross enrolment ratio (%) in Secondary schools?
Offer a terse response. 66.23. In the year 1981, what is the difference between the Gross enrolment ratio (%) in Primary schools and Gross enrolment ratio (%) in Tertiary schools?
Your response must be concise. 95.6. In the year 1981, what is the difference between the Gross enrolment ratio (%) of Secondary schools and Gross enrolment ratio (%) of Tertiary schools?
Offer a very short reply. 29.37. In the year 1982, what is the difference between the Gross enrolment ratio (%) in Pre-primary schools and Gross enrolment ratio (%) in Primary schools?
Your answer should be very brief. -92.85. In the year 1982, what is the difference between the Gross enrolment ratio (%) of Pre-primary schools and Gross enrolment ratio (%) of Secondary schools?
Your answer should be very brief. -28.1. In the year 1982, what is the difference between the Gross enrolment ratio (%) in Pre-primary schools and Gross enrolment ratio (%) in Tertiary schools?
Provide a short and direct response. 2.64. In the year 1982, what is the difference between the Gross enrolment ratio (%) of Primary schools and Gross enrolment ratio (%) of Secondary schools?
Ensure brevity in your answer.  64.75. In the year 1982, what is the difference between the Gross enrolment ratio (%) in Primary schools and Gross enrolment ratio (%) in Tertiary schools?
Provide a short and direct response. 95.49. In the year 1982, what is the difference between the Gross enrolment ratio (%) of Secondary schools and Gross enrolment ratio (%) of Tertiary schools?
Make the answer very short. 30.74. What is the ratio of the Gross enrolment ratio (%) in Pre-primary schools in 1976 to that in 1977?
Keep it short and to the point. 0.87. What is the ratio of the Gross enrolment ratio (%) in Primary schools in 1976 to that in 1977?
Your response must be concise. 0.9. What is the ratio of the Gross enrolment ratio (%) of Secondary schools in 1976 to that in 1977?
Give a very brief answer. 0.89. What is the ratio of the Gross enrolment ratio (%) in Tertiary schools in 1976 to that in 1977?
Provide a succinct answer. 0.95. What is the ratio of the Gross enrolment ratio (%) of Pre-primary schools in 1976 to that in 1978?
Make the answer very short. 0.8. What is the ratio of the Gross enrolment ratio (%) in Primary schools in 1976 to that in 1978?
Provide a succinct answer. 0.85. What is the ratio of the Gross enrolment ratio (%) in Secondary schools in 1976 to that in 1978?
Make the answer very short. 0.79. What is the ratio of the Gross enrolment ratio (%) of Tertiary schools in 1976 to that in 1978?
Your response must be concise. 0.93. What is the ratio of the Gross enrolment ratio (%) in Pre-primary schools in 1976 to that in 1979?
Make the answer very short. 0.68. What is the ratio of the Gross enrolment ratio (%) in Primary schools in 1976 to that in 1979?
Provide a succinct answer. 0.64. What is the ratio of the Gross enrolment ratio (%) in Secondary schools in 1976 to that in 1979?
Offer a very short reply. 0.7. What is the ratio of the Gross enrolment ratio (%) in Tertiary schools in 1976 to that in 1979?
Offer a very short reply. 0.96. What is the ratio of the Gross enrolment ratio (%) of Pre-primary schools in 1976 to that in 1980?
Provide a short and direct response. 0.66. What is the ratio of the Gross enrolment ratio (%) of Primary schools in 1976 to that in 1980?
Ensure brevity in your answer.  0.59. What is the ratio of the Gross enrolment ratio (%) of Secondary schools in 1976 to that in 1980?
Make the answer very short. 0.64. What is the ratio of the Gross enrolment ratio (%) in Tertiary schools in 1976 to that in 1980?
Provide a short and direct response. 0.92. What is the ratio of the Gross enrolment ratio (%) of Pre-primary schools in 1976 to that in 1981?
Make the answer very short. 0.61. What is the ratio of the Gross enrolment ratio (%) of Primary schools in 1976 to that in 1981?
Provide a short and direct response. 0.58. What is the ratio of the Gross enrolment ratio (%) in Secondary schools in 1976 to that in 1981?
Ensure brevity in your answer.  0.61. What is the ratio of the Gross enrolment ratio (%) of Tertiary schools in 1976 to that in 1981?
Offer a very short reply. 0.87. What is the ratio of the Gross enrolment ratio (%) of Pre-primary schools in 1976 to that in 1982?
Your response must be concise. 0.59. What is the ratio of the Gross enrolment ratio (%) in Primary schools in 1976 to that in 1982?
Make the answer very short. 0.58. What is the ratio of the Gross enrolment ratio (%) in Secondary schools in 1976 to that in 1982?
Give a very brief answer. 0.58. What is the ratio of the Gross enrolment ratio (%) in Tertiary schools in 1976 to that in 1982?
Your answer should be compact. 0.86. What is the ratio of the Gross enrolment ratio (%) in Pre-primary schools in 1977 to that in 1978?
Your answer should be compact. 0.93. What is the ratio of the Gross enrolment ratio (%) in Primary schools in 1977 to that in 1978?
Offer a very short reply. 0.94. What is the ratio of the Gross enrolment ratio (%) of Secondary schools in 1977 to that in 1978?
Provide a succinct answer. 0.88. What is the ratio of the Gross enrolment ratio (%) of Tertiary schools in 1977 to that in 1978?
Make the answer very short. 0.97. What is the ratio of the Gross enrolment ratio (%) in Pre-primary schools in 1977 to that in 1979?
Offer a terse response. 0.78. What is the ratio of the Gross enrolment ratio (%) in Primary schools in 1977 to that in 1979?
Provide a short and direct response. 0.7. What is the ratio of the Gross enrolment ratio (%) in Secondary schools in 1977 to that in 1979?
Your response must be concise. 0.79. What is the ratio of the Gross enrolment ratio (%) of Pre-primary schools in 1977 to that in 1980?
Ensure brevity in your answer.  0.76. What is the ratio of the Gross enrolment ratio (%) in Primary schools in 1977 to that in 1980?
Provide a short and direct response. 0.65. What is the ratio of the Gross enrolment ratio (%) of Secondary schools in 1977 to that in 1980?
Your answer should be very brief. 0.72. What is the ratio of the Gross enrolment ratio (%) in Tertiary schools in 1977 to that in 1980?
Make the answer very short. 0.97. What is the ratio of the Gross enrolment ratio (%) in Pre-primary schools in 1977 to that in 1981?
Your response must be concise. 0.7. What is the ratio of the Gross enrolment ratio (%) in Primary schools in 1977 to that in 1981?
Give a very brief answer. 0.64. What is the ratio of the Gross enrolment ratio (%) of Secondary schools in 1977 to that in 1981?
Your response must be concise. 0.68. What is the ratio of the Gross enrolment ratio (%) of Tertiary schools in 1977 to that in 1981?
Keep it short and to the point. 0.92. What is the ratio of the Gross enrolment ratio (%) of Pre-primary schools in 1977 to that in 1982?
Your answer should be compact. 0.67. What is the ratio of the Gross enrolment ratio (%) in Primary schools in 1977 to that in 1982?
Keep it short and to the point. 0.64. What is the ratio of the Gross enrolment ratio (%) in Secondary schools in 1977 to that in 1982?
Make the answer very short. 0.65. What is the ratio of the Gross enrolment ratio (%) in Tertiary schools in 1977 to that in 1982?
Your response must be concise. 0.9. What is the ratio of the Gross enrolment ratio (%) in Pre-primary schools in 1978 to that in 1979?
Your answer should be very brief. 0.84. What is the ratio of the Gross enrolment ratio (%) of Primary schools in 1978 to that in 1979?
Your answer should be compact. 0.75. What is the ratio of the Gross enrolment ratio (%) in Secondary schools in 1978 to that in 1979?
Offer a terse response. 0.9. What is the ratio of the Gross enrolment ratio (%) of Tertiary schools in 1978 to that in 1979?
Give a very brief answer. 1.03. What is the ratio of the Gross enrolment ratio (%) of Pre-primary schools in 1978 to that in 1980?
Your response must be concise. 0.82. What is the ratio of the Gross enrolment ratio (%) of Primary schools in 1978 to that in 1980?
Provide a short and direct response. 0.69. What is the ratio of the Gross enrolment ratio (%) in Secondary schools in 1978 to that in 1980?
Keep it short and to the point. 0.82. What is the ratio of the Gross enrolment ratio (%) of Tertiary schools in 1978 to that in 1980?
Offer a terse response. 0.99. What is the ratio of the Gross enrolment ratio (%) of Pre-primary schools in 1978 to that in 1981?
Provide a succinct answer. 0.76. What is the ratio of the Gross enrolment ratio (%) in Primary schools in 1978 to that in 1981?
Provide a succinct answer. 0.68. What is the ratio of the Gross enrolment ratio (%) of Secondary schools in 1978 to that in 1981?
Your answer should be very brief. 0.78. What is the ratio of the Gross enrolment ratio (%) of Tertiary schools in 1978 to that in 1981?
Give a very brief answer. 0.94. What is the ratio of the Gross enrolment ratio (%) of Pre-primary schools in 1978 to that in 1982?
Keep it short and to the point. 0.73. What is the ratio of the Gross enrolment ratio (%) in Primary schools in 1978 to that in 1982?
Your response must be concise. 0.68. What is the ratio of the Gross enrolment ratio (%) in Secondary schools in 1978 to that in 1982?
Offer a terse response. 0.74. What is the ratio of the Gross enrolment ratio (%) of Tertiary schools in 1978 to that in 1982?
Provide a succinct answer. 0.93. What is the ratio of the Gross enrolment ratio (%) in Pre-primary schools in 1979 to that in 1980?
Keep it short and to the point. 0.97. What is the ratio of the Gross enrolment ratio (%) of Primary schools in 1979 to that in 1980?
Provide a short and direct response. 0.92. What is the ratio of the Gross enrolment ratio (%) of Secondary schools in 1979 to that in 1980?
Give a very brief answer. 0.91. What is the ratio of the Gross enrolment ratio (%) of Pre-primary schools in 1979 to that in 1981?
Your answer should be very brief. 0.9. What is the ratio of the Gross enrolment ratio (%) of Primary schools in 1979 to that in 1981?
Ensure brevity in your answer.  0.91. What is the ratio of the Gross enrolment ratio (%) of Secondary schools in 1979 to that in 1981?
Ensure brevity in your answer.  0.86. What is the ratio of the Gross enrolment ratio (%) in Tertiary schools in 1979 to that in 1981?
Provide a short and direct response. 0.91. What is the ratio of the Gross enrolment ratio (%) of Pre-primary schools in 1979 to that in 1982?
Offer a terse response. 0.86. What is the ratio of the Gross enrolment ratio (%) in Primary schools in 1979 to that in 1982?
Provide a short and direct response. 0.91. What is the ratio of the Gross enrolment ratio (%) in Secondary schools in 1979 to that in 1982?
Give a very brief answer. 0.83. What is the ratio of the Gross enrolment ratio (%) of Tertiary schools in 1979 to that in 1982?
Keep it short and to the point. 0.9. What is the ratio of the Gross enrolment ratio (%) in Pre-primary schools in 1980 to that in 1981?
Your answer should be compact. 0.93. What is the ratio of the Gross enrolment ratio (%) of Primary schools in 1980 to that in 1981?
Your answer should be compact. 0.99. What is the ratio of the Gross enrolment ratio (%) in Secondary schools in 1980 to that in 1981?
Your response must be concise. 0.95. What is the ratio of the Gross enrolment ratio (%) in Tertiary schools in 1980 to that in 1981?
Provide a succinct answer. 0.95. What is the ratio of the Gross enrolment ratio (%) in Pre-primary schools in 1980 to that in 1982?
Your answer should be compact. 0.89. What is the ratio of the Gross enrolment ratio (%) of Secondary schools in 1980 to that in 1982?
Your answer should be very brief. 0.91. What is the ratio of the Gross enrolment ratio (%) of Tertiary schools in 1980 to that in 1982?
Your answer should be compact. 0.93. What is the ratio of the Gross enrolment ratio (%) of Pre-primary schools in 1981 to that in 1982?
Provide a short and direct response. 0.96. What is the ratio of the Gross enrolment ratio (%) of Secondary schools in 1981 to that in 1982?
Offer a very short reply. 0.96. What is the ratio of the Gross enrolment ratio (%) of Tertiary schools in 1981 to that in 1982?
Keep it short and to the point. 0.98. What is the difference between the highest and the second highest Gross enrolment ratio (%) in Pre-primary schools?
Your answer should be very brief. 0.36. What is the difference between the highest and the second highest Gross enrolment ratio (%) in Secondary schools?
Give a very brief answer. 1.48. What is the difference between the highest and the second highest Gross enrolment ratio (%) of Tertiary schools?
Provide a short and direct response. 0.1. What is the difference between the highest and the lowest Gross enrolment ratio (%) in Pre-primary schools?
Make the answer very short. 3.63. What is the difference between the highest and the lowest Gross enrolment ratio (%) in Primary schools?
Your answer should be compact. 42.71. What is the difference between the highest and the lowest Gross enrolment ratio (%) in Secondary schools?
Ensure brevity in your answer.  15.31. What is the difference between the highest and the lowest Gross enrolment ratio (%) of Tertiary schools?
Make the answer very short. 0.86. 